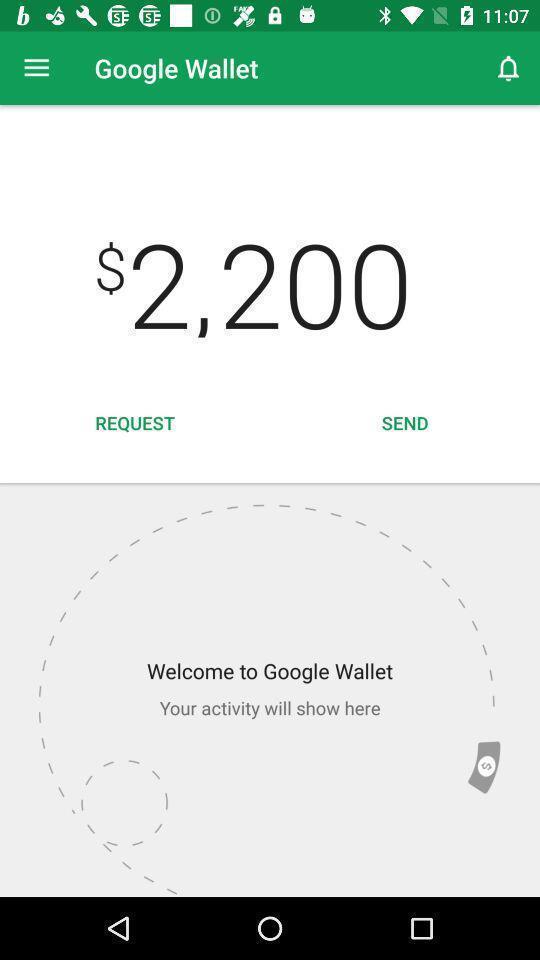Describe the key features of this screenshot. Welcome page of a financial app. 